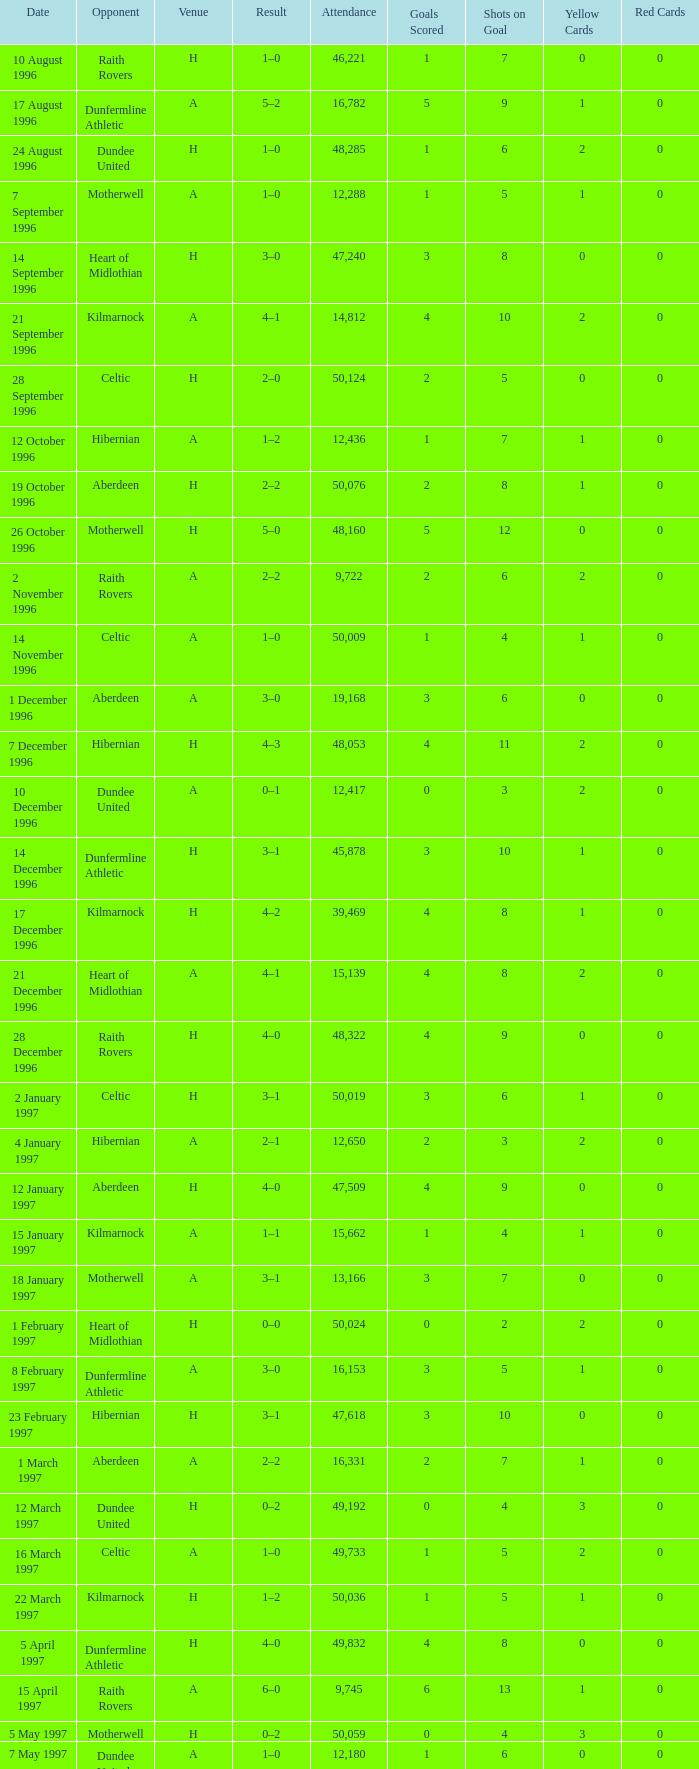When did venue A have an attendance larger than 48,053, and a result of 1–0? 14 November 1996, 16 March 1997. 